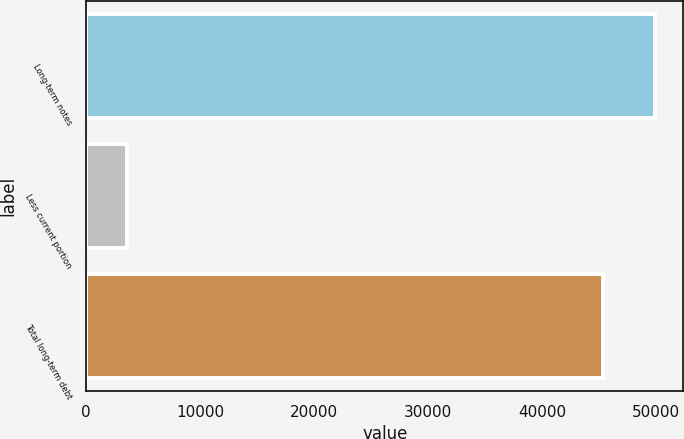<chart> <loc_0><loc_0><loc_500><loc_500><bar_chart><fcel>Long-term notes<fcel>Less current portion<fcel>Total long-term debt<nl><fcel>49915.8<fcel>3604<fcel>45378<nl></chart> 